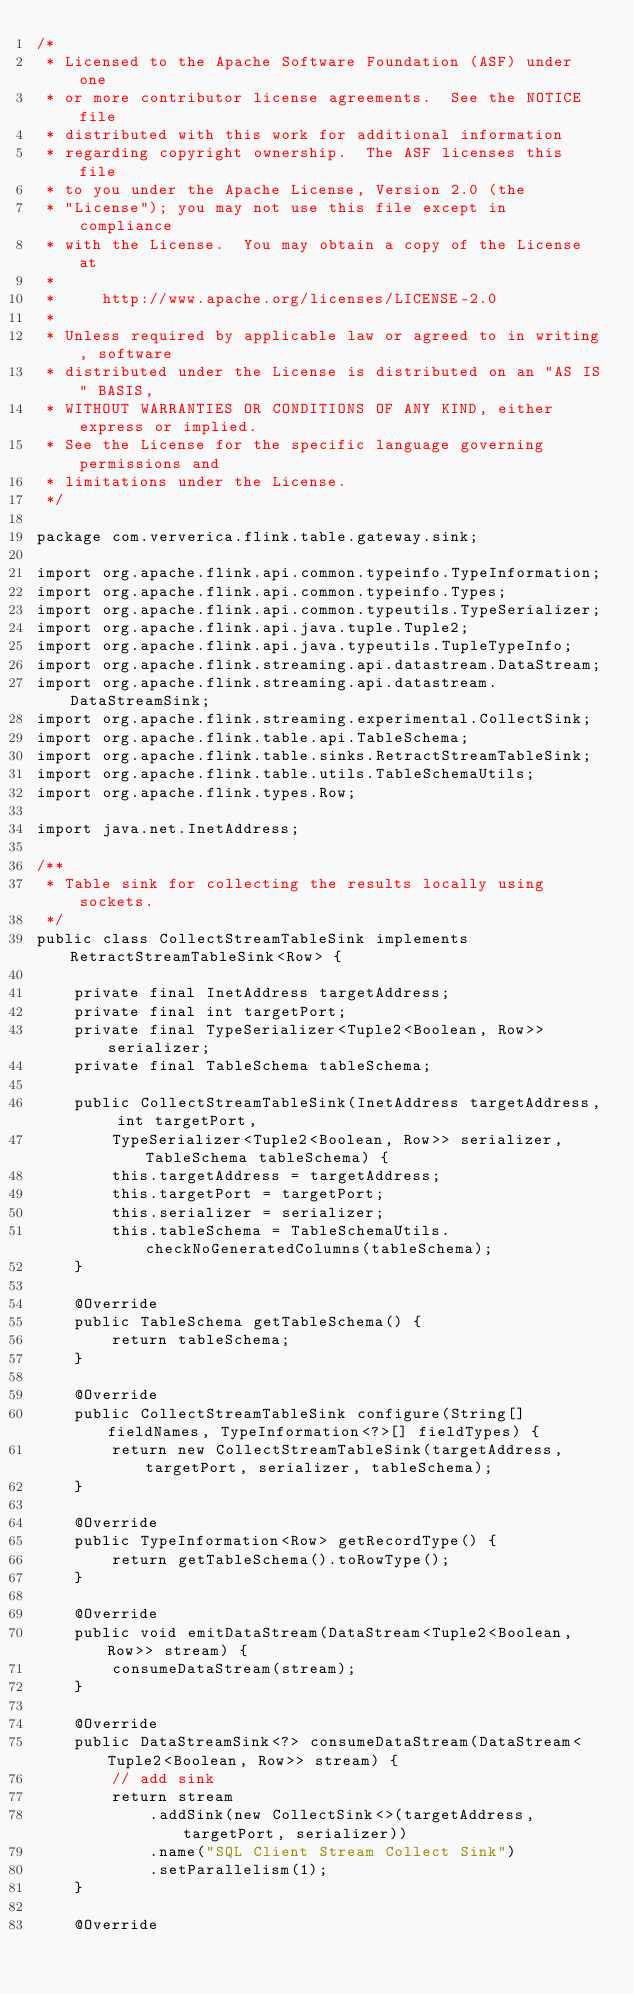<code> <loc_0><loc_0><loc_500><loc_500><_Java_>/*
 * Licensed to the Apache Software Foundation (ASF) under one
 * or more contributor license agreements.  See the NOTICE file
 * distributed with this work for additional information
 * regarding copyright ownership.  The ASF licenses this file
 * to you under the Apache License, Version 2.0 (the
 * "License"); you may not use this file except in compliance
 * with the License.  You may obtain a copy of the License at
 *
 *     http://www.apache.org/licenses/LICENSE-2.0
 *
 * Unless required by applicable law or agreed to in writing, software
 * distributed under the License is distributed on an "AS IS" BASIS,
 * WITHOUT WARRANTIES OR CONDITIONS OF ANY KIND, either express or implied.
 * See the License for the specific language governing permissions and
 * limitations under the License.
 */

package com.ververica.flink.table.gateway.sink;

import org.apache.flink.api.common.typeinfo.TypeInformation;
import org.apache.flink.api.common.typeinfo.Types;
import org.apache.flink.api.common.typeutils.TypeSerializer;
import org.apache.flink.api.java.tuple.Tuple2;
import org.apache.flink.api.java.typeutils.TupleTypeInfo;
import org.apache.flink.streaming.api.datastream.DataStream;
import org.apache.flink.streaming.api.datastream.DataStreamSink;
import org.apache.flink.streaming.experimental.CollectSink;
import org.apache.flink.table.api.TableSchema;
import org.apache.flink.table.sinks.RetractStreamTableSink;
import org.apache.flink.table.utils.TableSchemaUtils;
import org.apache.flink.types.Row;

import java.net.InetAddress;

/**
 * Table sink for collecting the results locally using sockets.
 */
public class CollectStreamTableSink implements RetractStreamTableSink<Row> {

	private final InetAddress targetAddress;
	private final int targetPort;
	private final TypeSerializer<Tuple2<Boolean, Row>> serializer;
	private final TableSchema tableSchema;

	public CollectStreamTableSink(InetAddress targetAddress, int targetPort,
		TypeSerializer<Tuple2<Boolean, Row>> serializer, TableSchema tableSchema) {
		this.targetAddress = targetAddress;
		this.targetPort = targetPort;
		this.serializer = serializer;
		this.tableSchema = TableSchemaUtils.checkNoGeneratedColumns(tableSchema);
	}

	@Override
	public TableSchema getTableSchema() {
		return tableSchema;
	}

	@Override
	public CollectStreamTableSink configure(String[] fieldNames, TypeInformation<?>[] fieldTypes) {
		return new CollectStreamTableSink(targetAddress, targetPort, serializer, tableSchema);
	}

	@Override
	public TypeInformation<Row> getRecordType() {
		return getTableSchema().toRowType();
	}

	@Override
	public void emitDataStream(DataStream<Tuple2<Boolean, Row>> stream) {
		consumeDataStream(stream);
	}

	@Override
	public DataStreamSink<?> consumeDataStream(DataStream<Tuple2<Boolean, Row>> stream) {
		// add sink
		return stream
			.addSink(new CollectSink<>(targetAddress, targetPort, serializer))
			.name("SQL Client Stream Collect Sink")
			.setParallelism(1);
	}

	@Override</code> 